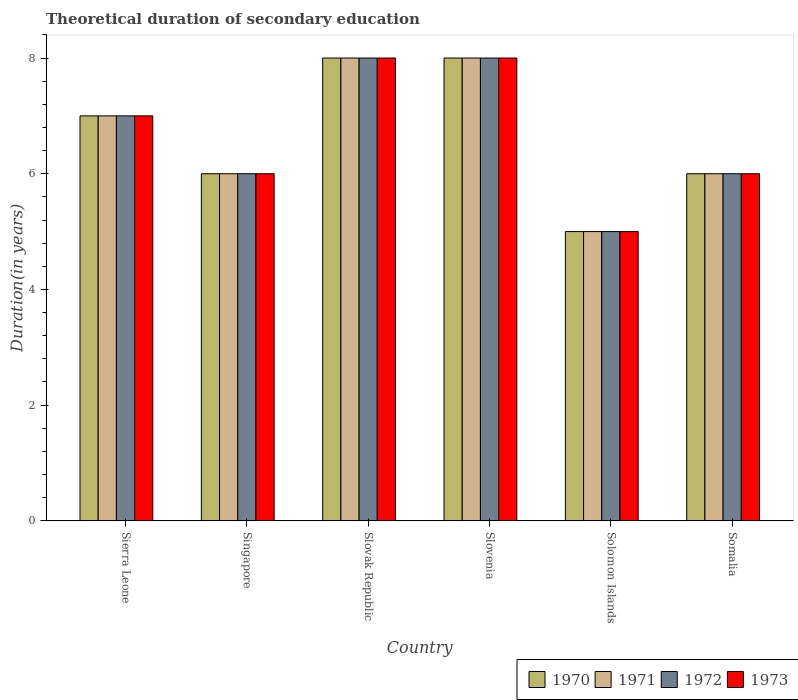How many different coloured bars are there?
Give a very brief answer. 4. How many groups of bars are there?
Give a very brief answer. 6. Are the number of bars per tick equal to the number of legend labels?
Ensure brevity in your answer.  Yes. What is the label of the 4th group of bars from the left?
Ensure brevity in your answer.  Slovenia. Across all countries, what is the maximum total theoretical duration of secondary education in 1972?
Offer a very short reply. 8. Across all countries, what is the minimum total theoretical duration of secondary education in 1971?
Give a very brief answer. 5. In which country was the total theoretical duration of secondary education in 1973 maximum?
Your answer should be very brief. Slovak Republic. In which country was the total theoretical duration of secondary education in 1973 minimum?
Keep it short and to the point. Solomon Islands. What is the total total theoretical duration of secondary education in 1971 in the graph?
Ensure brevity in your answer.  40. What is the difference between the total theoretical duration of secondary education in 1971 in Sierra Leone and that in Somalia?
Offer a terse response. 1. What is the average total theoretical duration of secondary education in 1971 per country?
Make the answer very short. 6.67. What is the difference between the total theoretical duration of secondary education of/in 1973 and total theoretical duration of secondary education of/in 1972 in Sierra Leone?
Provide a short and direct response. 0. What is the ratio of the total theoretical duration of secondary education in 1973 in Slovenia to that in Somalia?
Offer a terse response. 1.33. Is the difference between the total theoretical duration of secondary education in 1973 in Slovak Republic and Slovenia greater than the difference between the total theoretical duration of secondary education in 1972 in Slovak Republic and Slovenia?
Your answer should be very brief. No. Is it the case that in every country, the sum of the total theoretical duration of secondary education in 1971 and total theoretical duration of secondary education in 1970 is greater than the sum of total theoretical duration of secondary education in 1973 and total theoretical duration of secondary education in 1972?
Your response must be concise. No. What does the 3rd bar from the left in Slovenia represents?
Your answer should be compact. 1972. How many bars are there?
Make the answer very short. 24. How many countries are there in the graph?
Your response must be concise. 6. Are the values on the major ticks of Y-axis written in scientific E-notation?
Provide a short and direct response. No. Does the graph contain any zero values?
Your response must be concise. No. Where does the legend appear in the graph?
Your response must be concise. Bottom right. How are the legend labels stacked?
Ensure brevity in your answer.  Horizontal. What is the title of the graph?
Ensure brevity in your answer.  Theoretical duration of secondary education. Does "1990" appear as one of the legend labels in the graph?
Ensure brevity in your answer.  No. What is the label or title of the Y-axis?
Keep it short and to the point. Duration(in years). What is the Duration(in years) of 1972 in Sierra Leone?
Keep it short and to the point. 7. What is the Duration(in years) in 1970 in Singapore?
Your answer should be very brief. 6. What is the Duration(in years) of 1972 in Singapore?
Make the answer very short. 6. What is the Duration(in years) of 1973 in Singapore?
Provide a short and direct response. 6. What is the Duration(in years) in 1972 in Slovak Republic?
Provide a short and direct response. 8. What is the Duration(in years) of 1973 in Slovak Republic?
Provide a short and direct response. 8. What is the Duration(in years) in 1970 in Slovenia?
Keep it short and to the point. 8. What is the Duration(in years) of 1971 in Slovenia?
Give a very brief answer. 8. What is the Duration(in years) in 1973 in Slovenia?
Make the answer very short. 8. What is the Duration(in years) in 1970 in Solomon Islands?
Make the answer very short. 5. What is the Duration(in years) of 1972 in Solomon Islands?
Provide a succinct answer. 5. What is the Duration(in years) of 1973 in Solomon Islands?
Give a very brief answer. 5. What is the Duration(in years) in 1970 in Somalia?
Provide a succinct answer. 6. What is the Duration(in years) of 1973 in Somalia?
Provide a succinct answer. 6. Across all countries, what is the maximum Duration(in years) in 1973?
Provide a short and direct response. 8. Across all countries, what is the minimum Duration(in years) of 1970?
Make the answer very short. 5. Across all countries, what is the minimum Duration(in years) in 1971?
Ensure brevity in your answer.  5. What is the total Duration(in years) of 1971 in the graph?
Your answer should be compact. 40. What is the difference between the Duration(in years) of 1970 in Sierra Leone and that in Slovak Republic?
Offer a very short reply. -1. What is the difference between the Duration(in years) of 1972 in Sierra Leone and that in Slovak Republic?
Make the answer very short. -1. What is the difference between the Duration(in years) of 1971 in Sierra Leone and that in Slovenia?
Your answer should be very brief. -1. What is the difference between the Duration(in years) in 1972 in Sierra Leone and that in Slovenia?
Make the answer very short. -1. What is the difference between the Duration(in years) of 1970 in Sierra Leone and that in Solomon Islands?
Ensure brevity in your answer.  2. What is the difference between the Duration(in years) of 1971 in Sierra Leone and that in Solomon Islands?
Offer a terse response. 2. What is the difference between the Duration(in years) of 1973 in Sierra Leone and that in Solomon Islands?
Your response must be concise. 2. What is the difference between the Duration(in years) of 1970 in Singapore and that in Slovenia?
Offer a terse response. -2. What is the difference between the Duration(in years) of 1972 in Singapore and that in Slovenia?
Give a very brief answer. -2. What is the difference between the Duration(in years) of 1973 in Singapore and that in Slovenia?
Your answer should be very brief. -2. What is the difference between the Duration(in years) of 1970 in Singapore and that in Solomon Islands?
Your answer should be very brief. 1. What is the difference between the Duration(in years) in 1971 in Singapore and that in Solomon Islands?
Your answer should be compact. 1. What is the difference between the Duration(in years) of 1972 in Singapore and that in Solomon Islands?
Keep it short and to the point. 1. What is the difference between the Duration(in years) in 1972 in Singapore and that in Somalia?
Offer a very short reply. 0. What is the difference between the Duration(in years) in 1971 in Slovak Republic and that in Slovenia?
Your answer should be compact. 0. What is the difference between the Duration(in years) of 1971 in Slovak Republic and that in Solomon Islands?
Your response must be concise. 3. What is the difference between the Duration(in years) in 1973 in Slovak Republic and that in Solomon Islands?
Provide a succinct answer. 3. What is the difference between the Duration(in years) of 1971 in Slovak Republic and that in Somalia?
Give a very brief answer. 2. What is the difference between the Duration(in years) of 1973 in Slovak Republic and that in Somalia?
Offer a very short reply. 2. What is the difference between the Duration(in years) of 1970 in Slovenia and that in Solomon Islands?
Provide a succinct answer. 3. What is the difference between the Duration(in years) in 1972 in Slovenia and that in Solomon Islands?
Provide a succinct answer. 3. What is the difference between the Duration(in years) of 1971 in Slovenia and that in Somalia?
Ensure brevity in your answer.  2. What is the difference between the Duration(in years) in 1972 in Slovenia and that in Somalia?
Ensure brevity in your answer.  2. What is the difference between the Duration(in years) of 1973 in Slovenia and that in Somalia?
Your answer should be very brief. 2. What is the difference between the Duration(in years) in 1971 in Solomon Islands and that in Somalia?
Provide a short and direct response. -1. What is the difference between the Duration(in years) in 1970 in Sierra Leone and the Duration(in years) in 1971 in Singapore?
Your response must be concise. 1. What is the difference between the Duration(in years) in 1970 in Sierra Leone and the Duration(in years) in 1972 in Singapore?
Provide a succinct answer. 1. What is the difference between the Duration(in years) of 1971 in Sierra Leone and the Duration(in years) of 1972 in Singapore?
Provide a short and direct response. 1. What is the difference between the Duration(in years) in 1971 in Sierra Leone and the Duration(in years) in 1973 in Singapore?
Give a very brief answer. 1. What is the difference between the Duration(in years) of 1970 in Sierra Leone and the Duration(in years) of 1971 in Slovak Republic?
Ensure brevity in your answer.  -1. What is the difference between the Duration(in years) of 1971 in Sierra Leone and the Duration(in years) of 1972 in Slovak Republic?
Your answer should be very brief. -1. What is the difference between the Duration(in years) of 1970 in Sierra Leone and the Duration(in years) of 1971 in Slovenia?
Provide a succinct answer. -1. What is the difference between the Duration(in years) of 1970 in Sierra Leone and the Duration(in years) of 1973 in Slovenia?
Ensure brevity in your answer.  -1. What is the difference between the Duration(in years) in 1971 in Sierra Leone and the Duration(in years) in 1973 in Slovenia?
Offer a very short reply. -1. What is the difference between the Duration(in years) of 1972 in Sierra Leone and the Duration(in years) of 1973 in Slovenia?
Provide a succinct answer. -1. What is the difference between the Duration(in years) of 1970 in Sierra Leone and the Duration(in years) of 1972 in Solomon Islands?
Keep it short and to the point. 2. What is the difference between the Duration(in years) in 1971 in Sierra Leone and the Duration(in years) in 1973 in Solomon Islands?
Make the answer very short. 2. What is the difference between the Duration(in years) in 1971 in Sierra Leone and the Duration(in years) in 1972 in Somalia?
Ensure brevity in your answer.  1. What is the difference between the Duration(in years) in 1970 in Singapore and the Duration(in years) in 1971 in Slovak Republic?
Offer a very short reply. -2. What is the difference between the Duration(in years) in 1971 in Singapore and the Duration(in years) in 1972 in Slovak Republic?
Keep it short and to the point. -2. What is the difference between the Duration(in years) of 1971 in Singapore and the Duration(in years) of 1973 in Slovak Republic?
Your response must be concise. -2. What is the difference between the Duration(in years) of 1972 in Singapore and the Duration(in years) of 1973 in Slovak Republic?
Provide a short and direct response. -2. What is the difference between the Duration(in years) of 1970 in Singapore and the Duration(in years) of 1972 in Slovenia?
Offer a very short reply. -2. What is the difference between the Duration(in years) in 1970 in Singapore and the Duration(in years) in 1973 in Slovenia?
Keep it short and to the point. -2. What is the difference between the Duration(in years) of 1971 in Singapore and the Duration(in years) of 1972 in Slovenia?
Provide a succinct answer. -2. What is the difference between the Duration(in years) of 1971 in Singapore and the Duration(in years) of 1973 in Slovenia?
Ensure brevity in your answer.  -2. What is the difference between the Duration(in years) of 1970 in Singapore and the Duration(in years) of 1972 in Solomon Islands?
Provide a succinct answer. 1. What is the difference between the Duration(in years) of 1970 in Singapore and the Duration(in years) of 1973 in Solomon Islands?
Give a very brief answer. 1. What is the difference between the Duration(in years) of 1970 in Singapore and the Duration(in years) of 1971 in Somalia?
Provide a succinct answer. 0. What is the difference between the Duration(in years) in 1970 in Singapore and the Duration(in years) in 1972 in Somalia?
Make the answer very short. 0. What is the difference between the Duration(in years) in 1971 in Singapore and the Duration(in years) in 1972 in Somalia?
Your answer should be very brief. 0. What is the difference between the Duration(in years) of 1970 in Slovak Republic and the Duration(in years) of 1971 in Slovenia?
Offer a very short reply. 0. What is the difference between the Duration(in years) of 1970 in Slovak Republic and the Duration(in years) of 1973 in Slovenia?
Give a very brief answer. 0. What is the difference between the Duration(in years) in 1971 in Slovak Republic and the Duration(in years) in 1973 in Slovenia?
Give a very brief answer. 0. What is the difference between the Duration(in years) in 1970 in Slovak Republic and the Duration(in years) in 1971 in Solomon Islands?
Ensure brevity in your answer.  3. What is the difference between the Duration(in years) of 1971 in Slovak Republic and the Duration(in years) of 1972 in Solomon Islands?
Make the answer very short. 3. What is the difference between the Duration(in years) in 1970 in Slovak Republic and the Duration(in years) in 1971 in Somalia?
Your response must be concise. 2. What is the difference between the Duration(in years) of 1970 in Slovak Republic and the Duration(in years) of 1973 in Somalia?
Provide a succinct answer. 2. What is the difference between the Duration(in years) in 1971 in Slovak Republic and the Duration(in years) in 1972 in Somalia?
Offer a very short reply. 2. What is the difference between the Duration(in years) in 1971 in Slovak Republic and the Duration(in years) in 1973 in Somalia?
Provide a succinct answer. 2. What is the difference between the Duration(in years) in 1970 in Slovenia and the Duration(in years) in 1973 in Solomon Islands?
Provide a short and direct response. 3. What is the difference between the Duration(in years) in 1971 in Slovenia and the Duration(in years) in 1972 in Solomon Islands?
Make the answer very short. 3. What is the difference between the Duration(in years) in 1971 in Slovenia and the Duration(in years) in 1973 in Solomon Islands?
Your answer should be very brief. 3. What is the difference between the Duration(in years) of 1970 in Slovenia and the Duration(in years) of 1972 in Somalia?
Your answer should be compact. 2. What is the difference between the Duration(in years) in 1971 in Slovenia and the Duration(in years) in 1972 in Somalia?
Make the answer very short. 2. What is the difference between the Duration(in years) of 1972 in Slovenia and the Duration(in years) of 1973 in Somalia?
Offer a very short reply. 2. What is the difference between the Duration(in years) of 1970 in Solomon Islands and the Duration(in years) of 1973 in Somalia?
Provide a short and direct response. -1. What is the difference between the Duration(in years) in 1971 in Solomon Islands and the Duration(in years) in 1973 in Somalia?
Provide a succinct answer. -1. What is the average Duration(in years) of 1970 per country?
Your response must be concise. 6.67. What is the average Duration(in years) in 1971 per country?
Provide a succinct answer. 6.67. What is the difference between the Duration(in years) in 1970 and Duration(in years) in 1972 in Sierra Leone?
Offer a terse response. 0. What is the difference between the Duration(in years) in 1971 and Duration(in years) in 1972 in Sierra Leone?
Keep it short and to the point. 0. What is the difference between the Duration(in years) in 1971 and Duration(in years) in 1973 in Sierra Leone?
Ensure brevity in your answer.  0. What is the difference between the Duration(in years) in 1970 and Duration(in years) in 1972 in Singapore?
Provide a short and direct response. 0. What is the difference between the Duration(in years) in 1970 and Duration(in years) in 1973 in Singapore?
Offer a very short reply. 0. What is the difference between the Duration(in years) of 1971 and Duration(in years) of 1972 in Singapore?
Your answer should be very brief. 0. What is the difference between the Duration(in years) in 1972 and Duration(in years) in 1973 in Slovak Republic?
Offer a terse response. 0. What is the difference between the Duration(in years) of 1970 and Duration(in years) of 1973 in Slovenia?
Keep it short and to the point. 0. What is the difference between the Duration(in years) in 1971 and Duration(in years) in 1972 in Slovenia?
Keep it short and to the point. 0. What is the difference between the Duration(in years) of 1970 and Duration(in years) of 1971 in Solomon Islands?
Make the answer very short. 0. What is the difference between the Duration(in years) of 1970 and Duration(in years) of 1973 in Solomon Islands?
Your response must be concise. 0. What is the difference between the Duration(in years) in 1970 and Duration(in years) in 1973 in Somalia?
Your answer should be compact. 0. What is the difference between the Duration(in years) in 1971 and Duration(in years) in 1972 in Somalia?
Your answer should be very brief. 0. What is the difference between the Duration(in years) of 1972 and Duration(in years) of 1973 in Somalia?
Give a very brief answer. 0. What is the ratio of the Duration(in years) in 1970 in Sierra Leone to that in Singapore?
Give a very brief answer. 1.17. What is the ratio of the Duration(in years) of 1973 in Sierra Leone to that in Singapore?
Your response must be concise. 1.17. What is the ratio of the Duration(in years) in 1971 in Sierra Leone to that in Slovak Republic?
Provide a succinct answer. 0.88. What is the ratio of the Duration(in years) in 1972 in Sierra Leone to that in Slovak Republic?
Make the answer very short. 0.88. What is the ratio of the Duration(in years) in 1970 in Sierra Leone to that in Slovenia?
Offer a terse response. 0.88. What is the ratio of the Duration(in years) of 1971 in Sierra Leone to that in Slovenia?
Offer a very short reply. 0.88. What is the ratio of the Duration(in years) in 1970 in Sierra Leone to that in Solomon Islands?
Your response must be concise. 1.4. What is the ratio of the Duration(in years) of 1972 in Sierra Leone to that in Solomon Islands?
Make the answer very short. 1.4. What is the ratio of the Duration(in years) in 1973 in Sierra Leone to that in Solomon Islands?
Your answer should be compact. 1.4. What is the ratio of the Duration(in years) of 1970 in Sierra Leone to that in Somalia?
Offer a very short reply. 1.17. What is the ratio of the Duration(in years) in 1972 in Sierra Leone to that in Somalia?
Ensure brevity in your answer.  1.17. What is the ratio of the Duration(in years) in 1970 in Singapore to that in Slovak Republic?
Your response must be concise. 0.75. What is the ratio of the Duration(in years) of 1972 in Singapore to that in Slovak Republic?
Your answer should be compact. 0.75. What is the ratio of the Duration(in years) of 1971 in Singapore to that in Slovenia?
Your answer should be very brief. 0.75. What is the ratio of the Duration(in years) of 1973 in Singapore to that in Slovenia?
Offer a very short reply. 0.75. What is the ratio of the Duration(in years) of 1972 in Singapore to that in Solomon Islands?
Your answer should be very brief. 1.2. What is the ratio of the Duration(in years) in 1972 in Singapore to that in Somalia?
Keep it short and to the point. 1. What is the ratio of the Duration(in years) in 1973 in Singapore to that in Somalia?
Provide a short and direct response. 1. What is the ratio of the Duration(in years) in 1972 in Slovak Republic to that in Slovenia?
Provide a succinct answer. 1. What is the ratio of the Duration(in years) of 1970 in Slovak Republic to that in Solomon Islands?
Offer a terse response. 1.6. What is the ratio of the Duration(in years) in 1971 in Slovak Republic to that in Solomon Islands?
Offer a very short reply. 1.6. What is the ratio of the Duration(in years) in 1973 in Slovak Republic to that in Solomon Islands?
Your answer should be compact. 1.6. What is the ratio of the Duration(in years) of 1970 in Slovak Republic to that in Somalia?
Offer a very short reply. 1.33. What is the ratio of the Duration(in years) of 1973 in Slovak Republic to that in Somalia?
Your answer should be very brief. 1.33. What is the ratio of the Duration(in years) of 1970 in Slovenia to that in Somalia?
Provide a short and direct response. 1.33. What is the ratio of the Duration(in years) of 1972 in Slovenia to that in Somalia?
Give a very brief answer. 1.33. What is the ratio of the Duration(in years) of 1973 in Slovenia to that in Somalia?
Your answer should be very brief. 1.33. What is the ratio of the Duration(in years) of 1970 in Solomon Islands to that in Somalia?
Give a very brief answer. 0.83. What is the difference between the highest and the second highest Duration(in years) of 1971?
Keep it short and to the point. 0. What is the difference between the highest and the second highest Duration(in years) in 1972?
Your response must be concise. 0. What is the difference between the highest and the second highest Duration(in years) of 1973?
Your answer should be compact. 0. What is the difference between the highest and the lowest Duration(in years) of 1971?
Make the answer very short. 3. What is the difference between the highest and the lowest Duration(in years) of 1973?
Offer a very short reply. 3. 